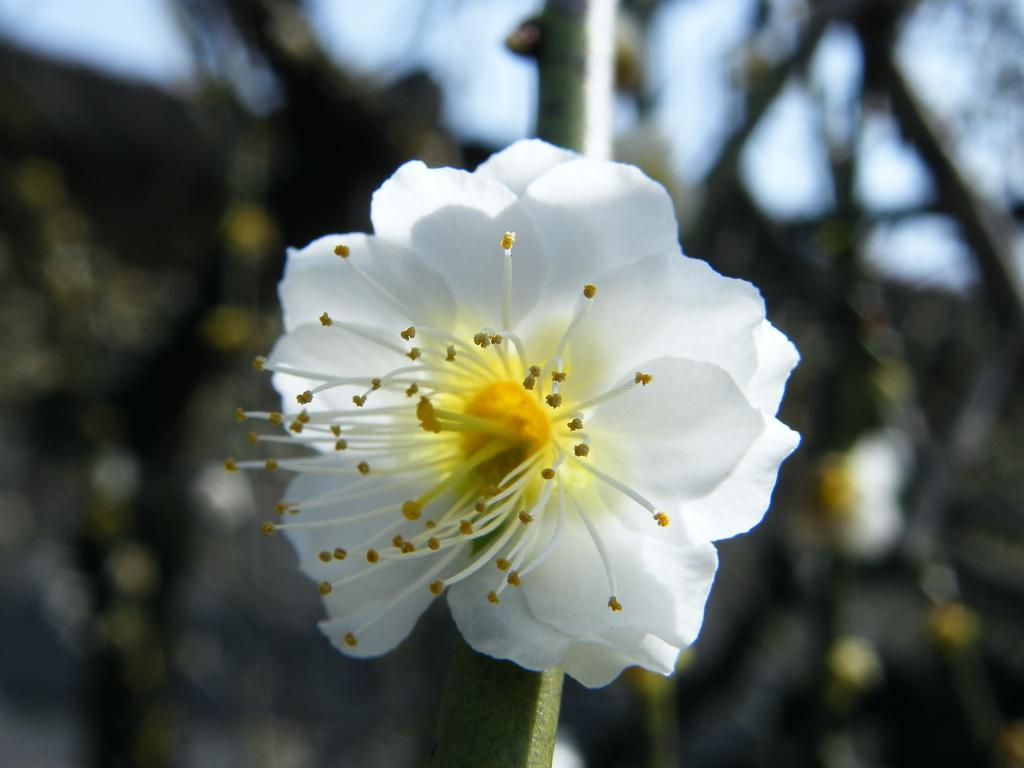What type of flower is in the image? There is a white color flower in the image. Can you describe the background of the image? The background of the image is blurry. What type of pickle is sitting next to the flower in the image? There is no pickle present in the image; it only features a white color flower. Who is the owner of the flower in the image? The image does not provide information about the owner of the flower. 